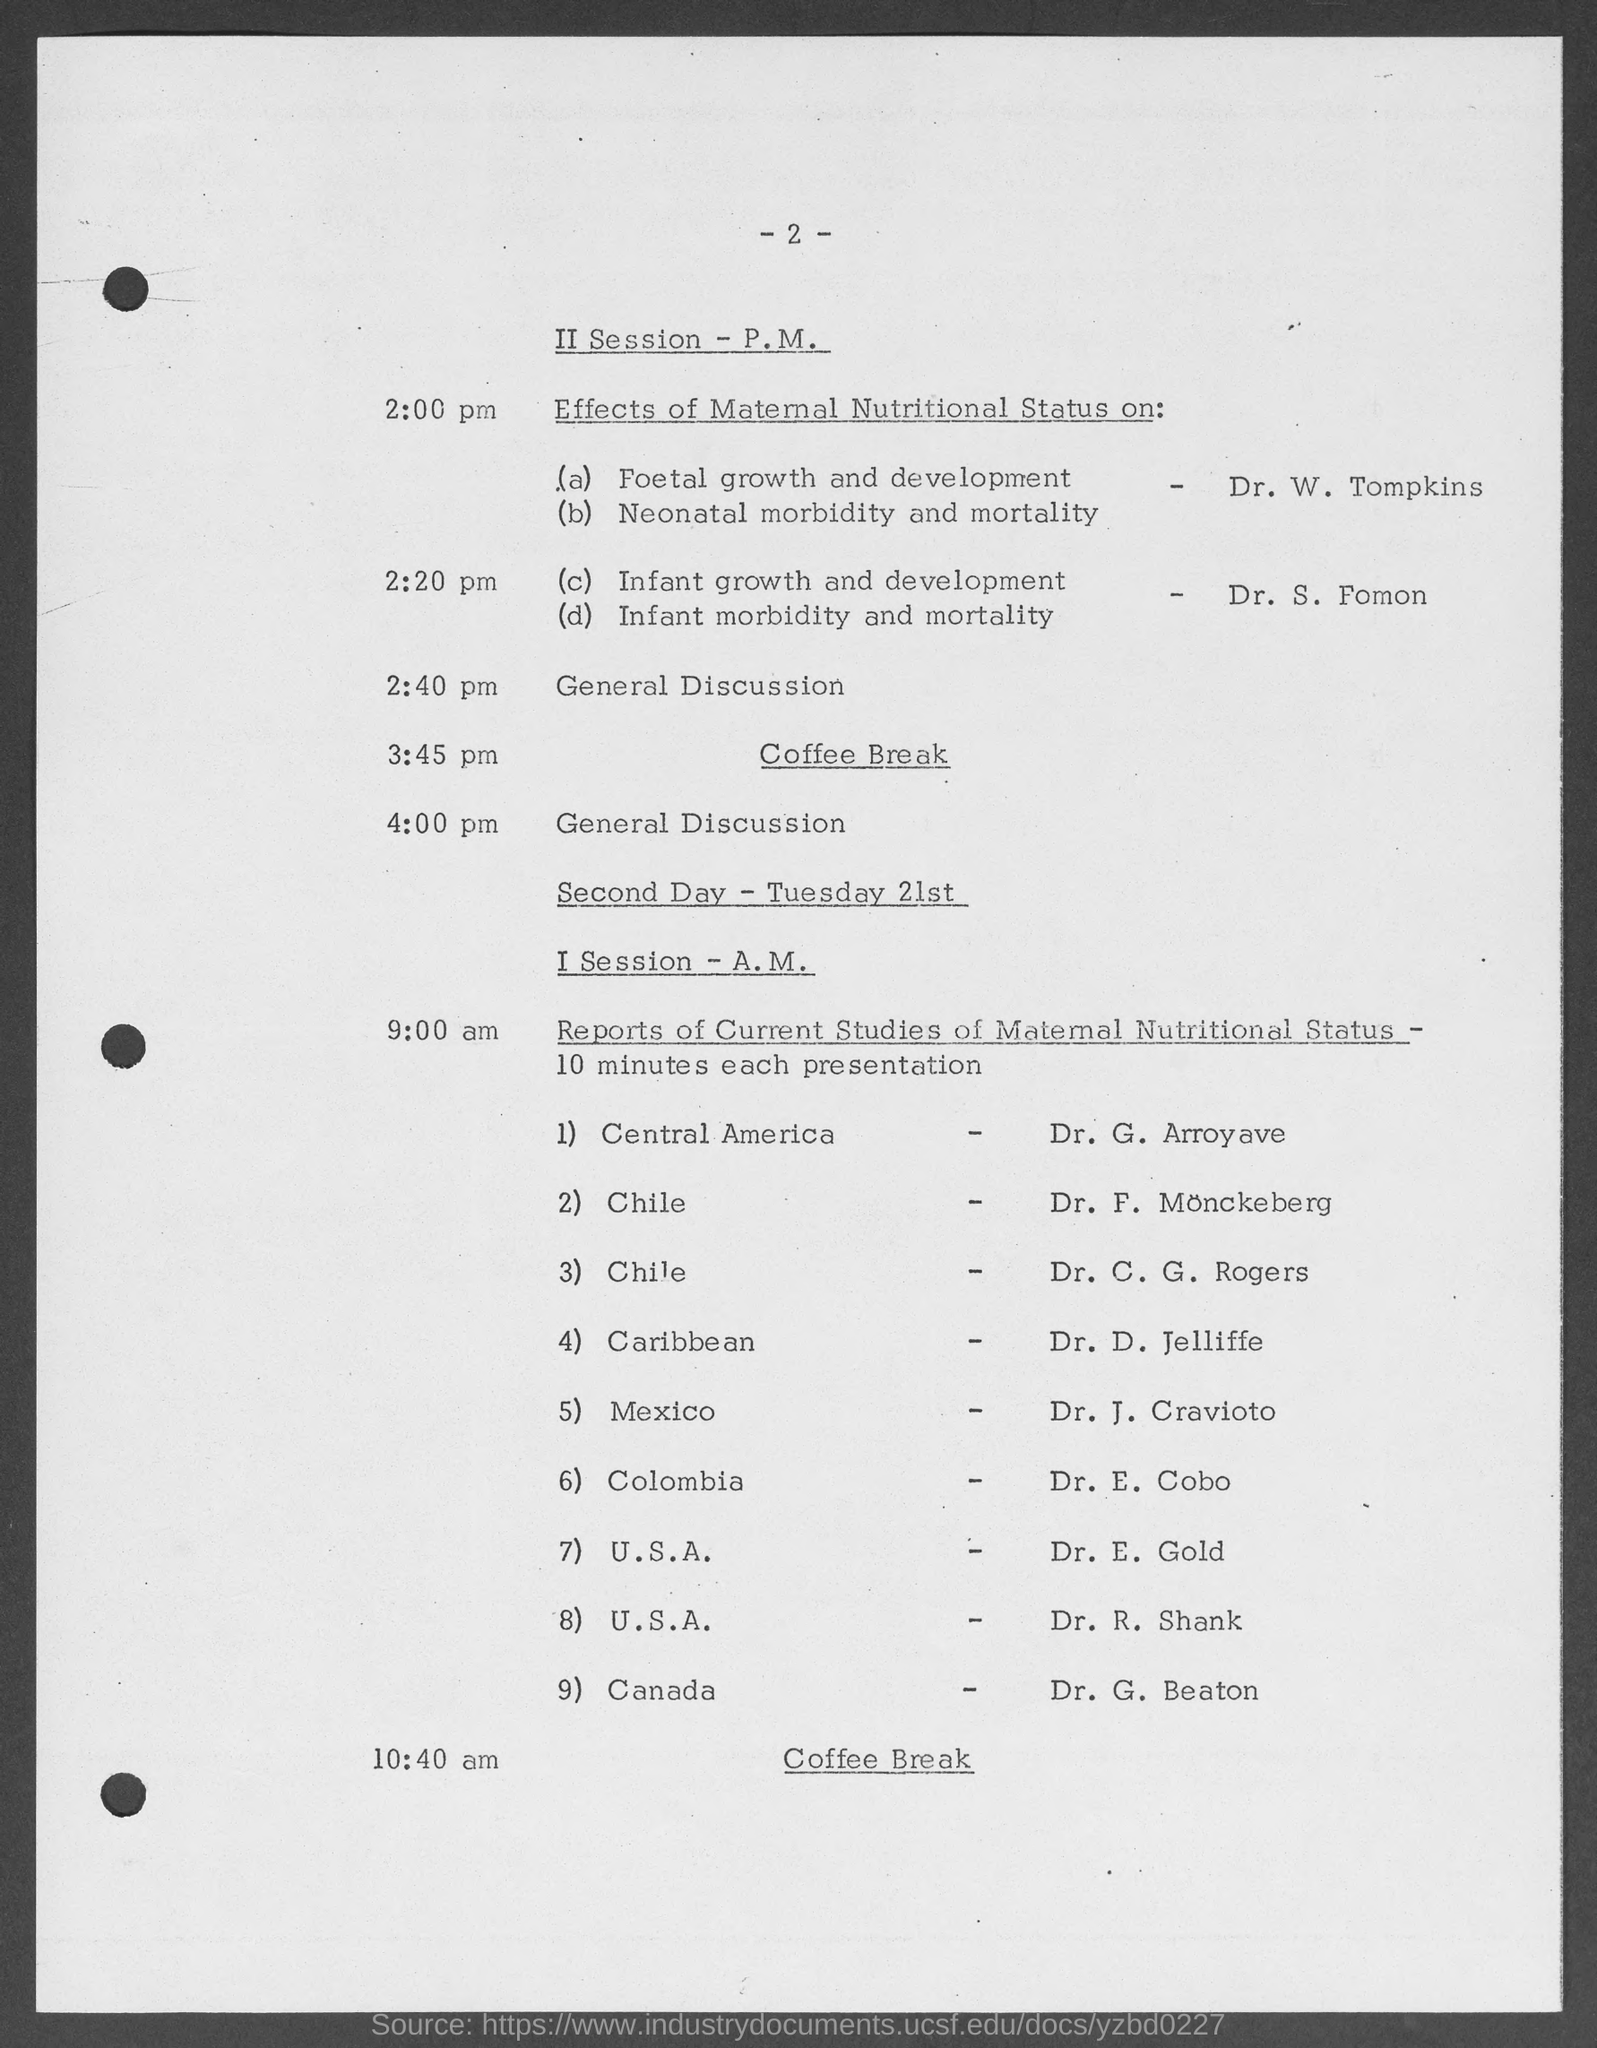Draw attention to some important aspects in this diagram. The coffee break on the second day is scheduled for 10:40 a.m. It has been announced that Dr. W. Tompkins will be presenting on the topic of "foetal growth and development. The general discussion will commence at 2:40 pm. 